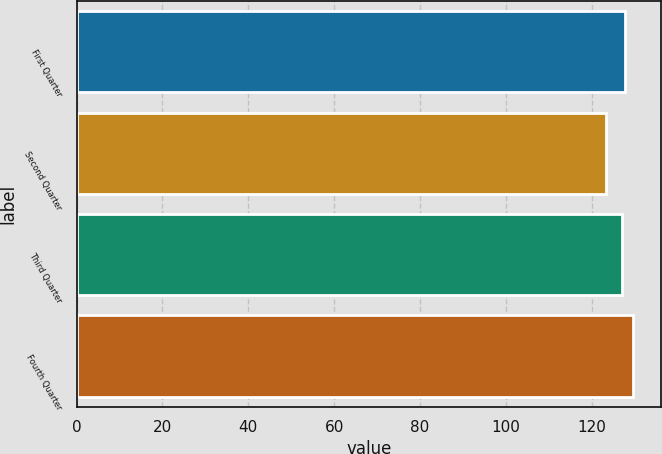Convert chart to OTSL. <chart><loc_0><loc_0><loc_500><loc_500><bar_chart><fcel>First Quarter<fcel>Second Quarter<fcel>Third Quarter<fcel>Fourth Quarter<nl><fcel>127.85<fcel>123.37<fcel>127.21<fcel>129.77<nl></chart> 